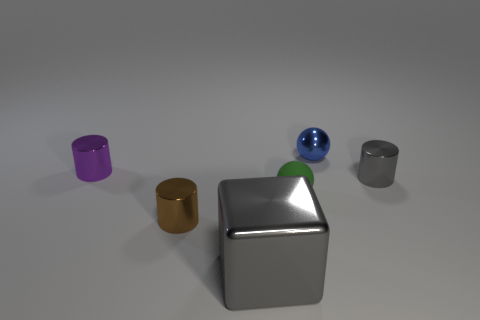Add 2 small brown spheres. How many objects exist? 8 Subtract all blocks. How many objects are left? 5 Subtract 0 cyan cylinders. How many objects are left? 6 Subtract all large gray metallic objects. Subtract all small blue shiny things. How many objects are left? 4 Add 1 small blue objects. How many small blue objects are left? 2 Add 2 brown metallic cylinders. How many brown metallic cylinders exist? 3 